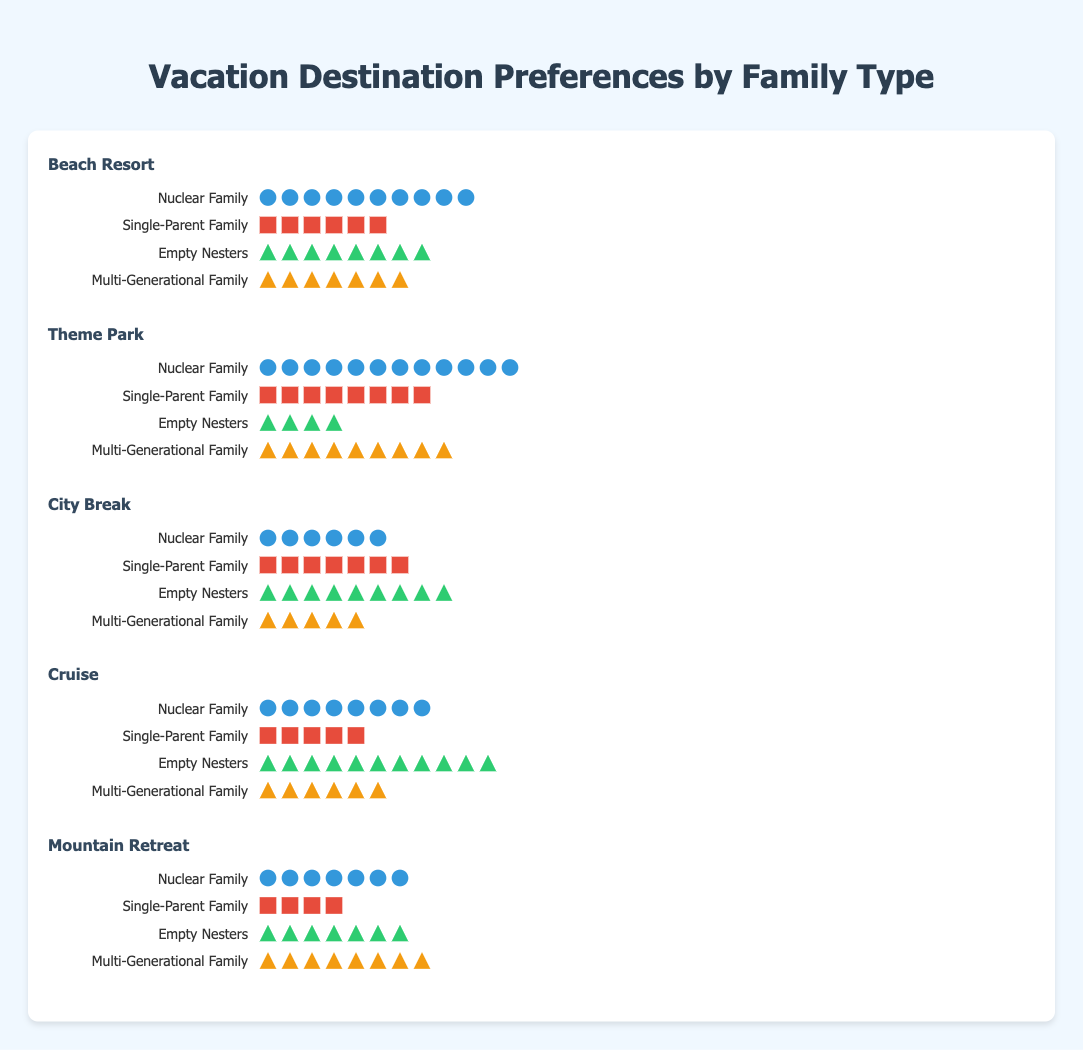What family type has the highest preference for a Beach Resort? The highest preference for a Beach Resort is indicated by the family type with the most icons in the corresponding section. The Nuclear Family has 10 icons, which is the highest among all family types.
Answer: Nuclear Family Which vacation destination is the least preferred by Empty Nesters? The least preferred destination by Empty Nesters is the one with the fewest icons in the corresponding section. The Theme Park has only 4 icons, which is the fewest among all destinations for Empty Nesters.
Answer: Theme Park Compare the preference for a Cruise between Single-Parent Families and Multi-Generational Families. To compare, check the number of icons for both family types in the Cruise section. Single-Parent Families have 5 icons, while Multi-Generational Families have 6 icons. Therefore, Multi-Generational Families prefer a Cruise more.
Answer: Multi-Generational Families What is the combined preference count for City Break among all family types? To find the combined preference count, add up the number of icons for each family type for City Break: 6 (Nuclear Family) + 7 (Single-Parent Family) + 9 (Empty Nesters) + 5 (Multi-Generational Family) = 27.
Answer: 27 Which destination has the most balanced preference among all family types? The most balanced preference is indicated by the destination where the preferences (icons) among family types do not show extreme variation. Mountain Retreat has preferences of 7, 4, 7, and 8, which shows relatively balanced interest among family types.
Answer: Mountain Retreat How much greater is the preference for Theme Park by Nuclear Families compared to Empty Nesters? The difference is calculated by subtracting the number of icons representing Empty Nesters' preference from the Nuclear Family's preference: 12 (Nuclear Family) - 4 (Empty Nesters) = 8.
Answer: 8 What family type has equal preferences for both Beach Resort and Mountain Retreat? To find this, compare the number of icons for each family type between Beach Resort and Mountain Retreat. Empty Nesters have an equal preference for both with 8 icons each.
Answer: Empty Nesters Identify the most preferred vacation destination for Single-Parent Families. The most preferred destination for Single-Parent Families is the one with the most icons in the corresponding section. Theme Park has 8 icons, which is the highest preference shown by Single-Parent Families.
Answer: Theme Park Which destination has the second highest preference among Nuclear Families? To find the second highest preference, look at the icons for Nuclear Families across all destinations and identify the next highest after the top one. Beach Resort has 10 icons, Theme Park has 12, City Break has 6, Cruise has 8, and Mountain Retreat has 7. So the second highest preference is Cruise with 8 icons.
Answer: Cruise 